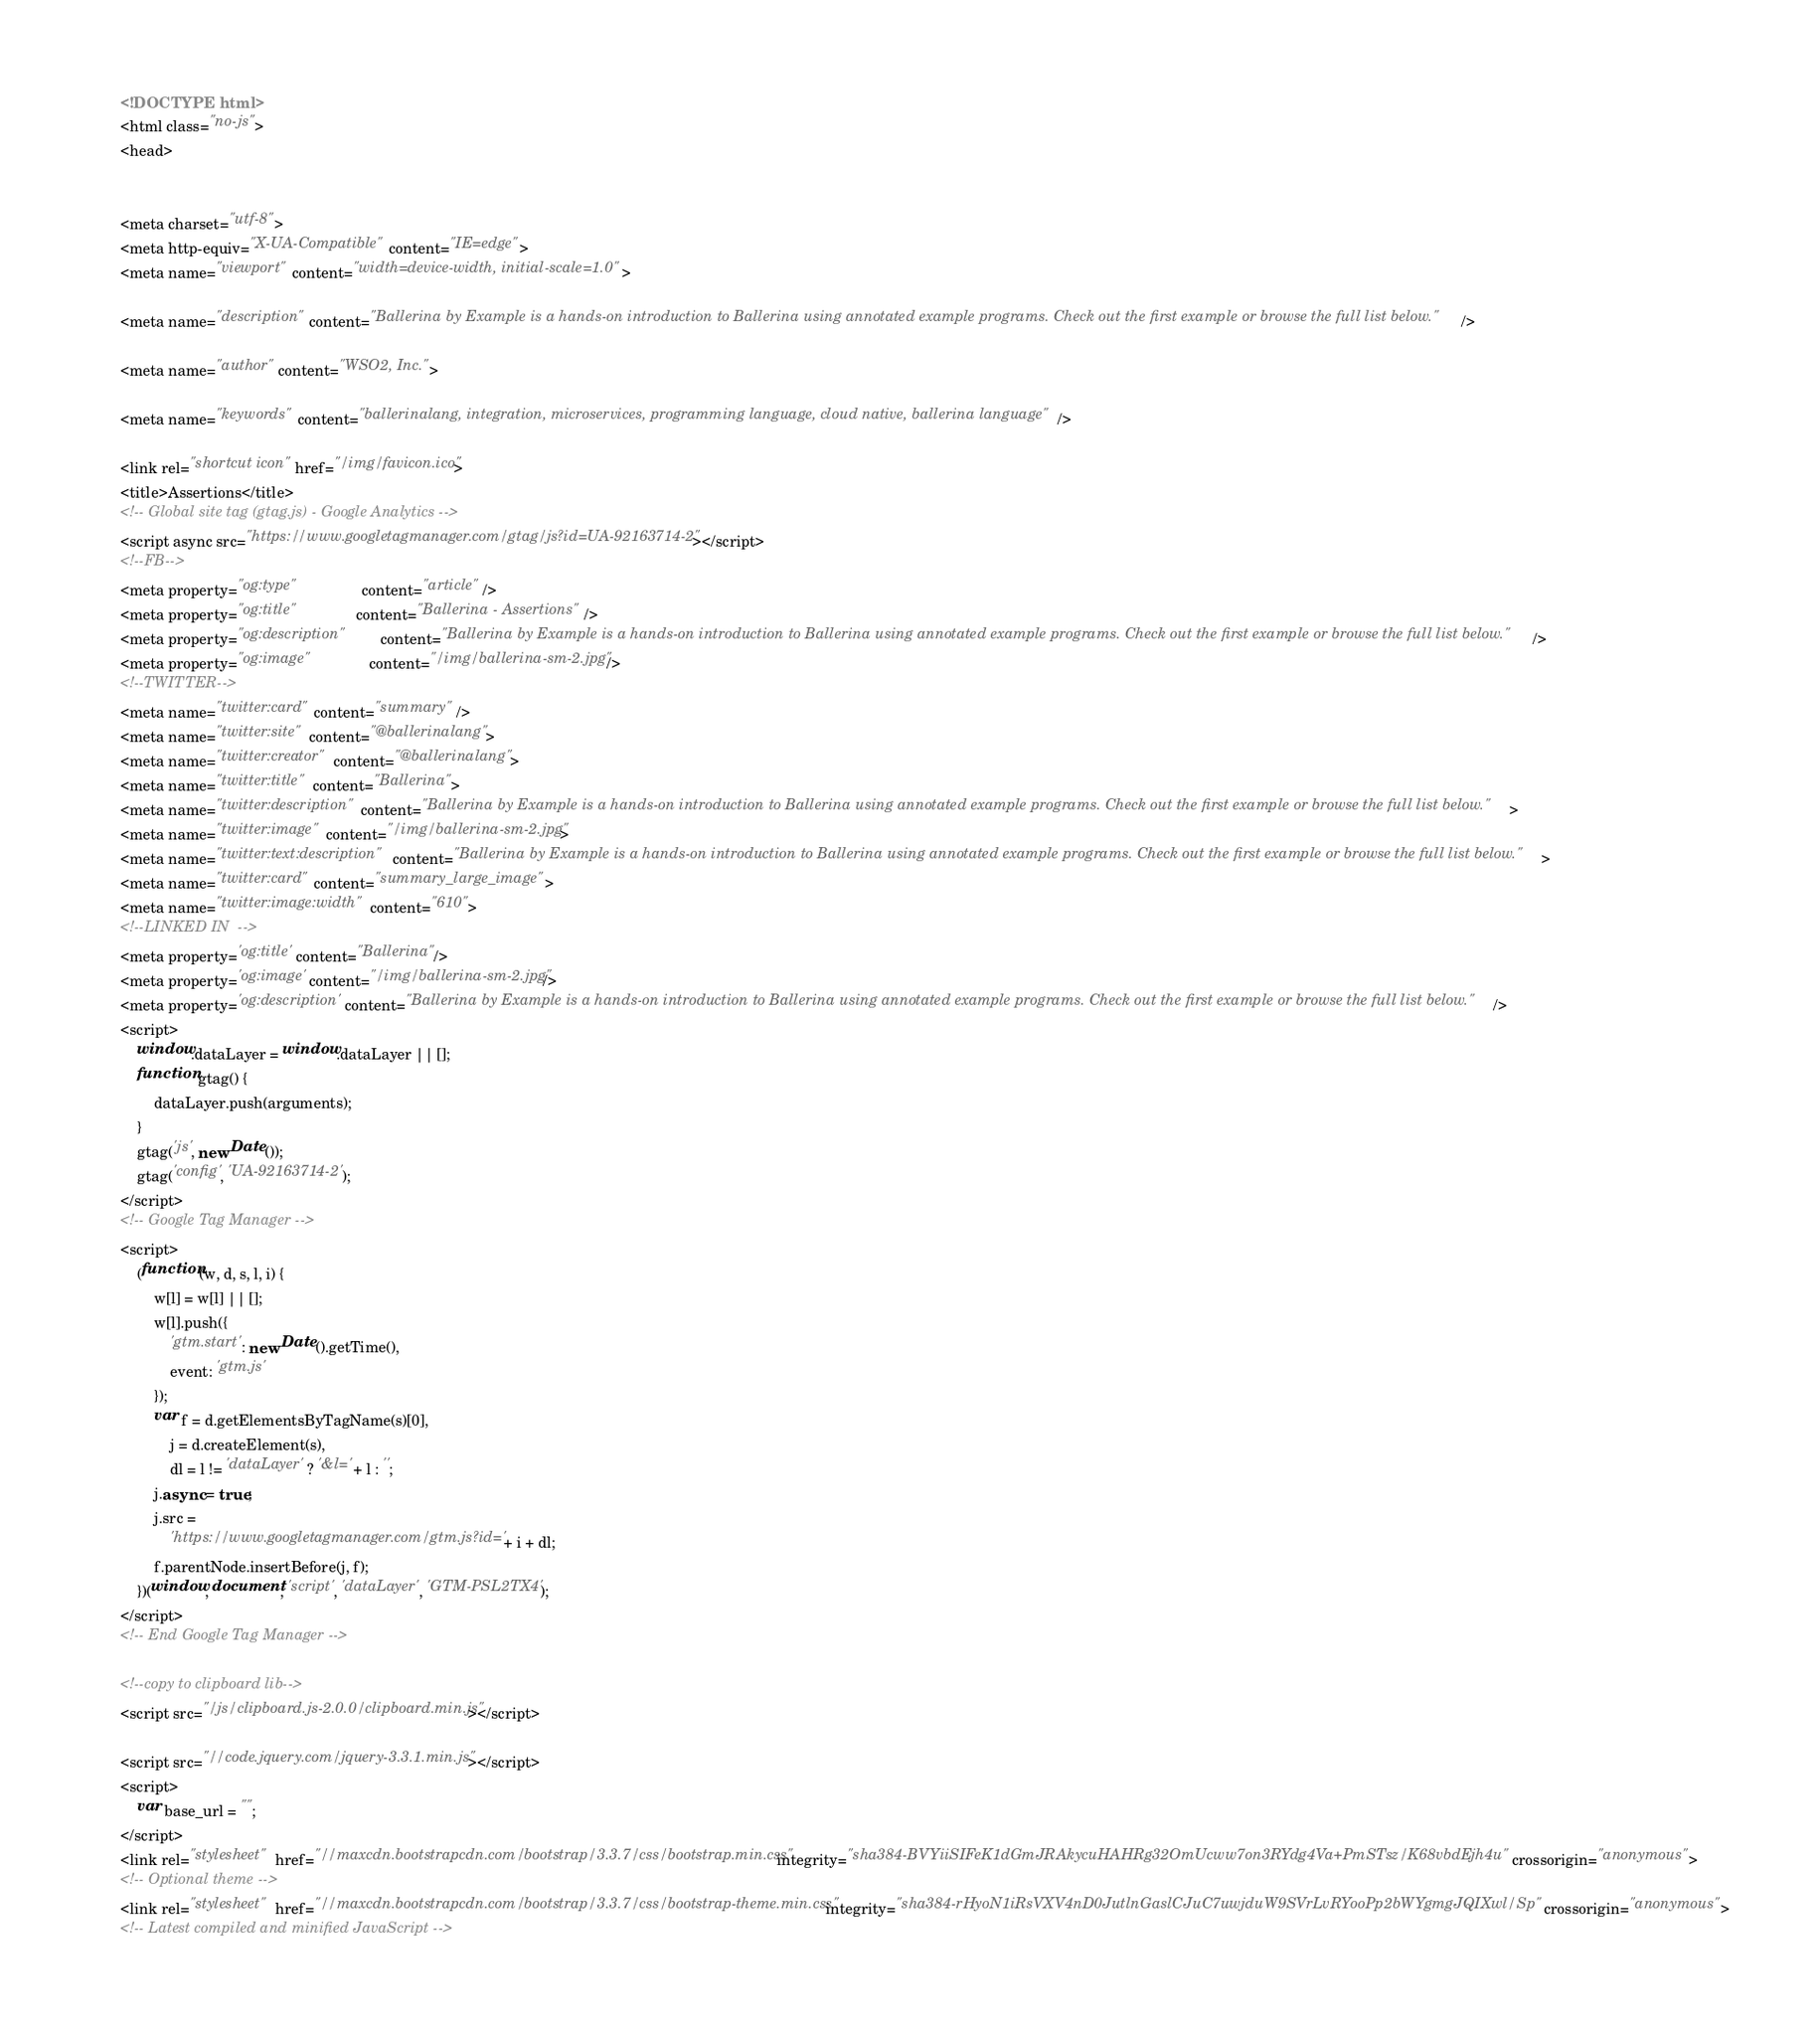<code> <loc_0><loc_0><loc_500><loc_500><_HTML_>

<!DOCTYPE html>
<html class="no-js">
<head>
    

<meta charset="utf-8">
<meta http-equiv="X-UA-Compatible" content="IE=edge">
<meta name="viewport" content="width=device-width, initial-scale=1.0">

<meta name="description" content="Ballerina by Example is a hands-on introduction to Ballerina using annotated example programs. Check out the first example or browse the full list below." />

<meta name="author" content="WSO2, Inc.">

<meta name="keywords" content="ballerinalang, integration, microservices, programming language, cloud native, ballerina language" />

<link rel="shortcut icon" href="/img/favicon.ico">
<title>Assertions</title>
<!-- Global site tag (gtag.js) - Google Analytics -->
<script async src="https://www.googletagmanager.com/gtag/js?id=UA-92163714-2"></script>
<!--FB-->
<meta property="og:type"               content="article" />
<meta property="og:title"              content="Ballerina - Assertions" />
<meta property="og:description"        content="Ballerina by Example is a hands-on introduction to Ballerina using annotated example programs. Check out the first example or browse the full list below." />
<meta property="og:image"              content="/img/ballerina-sm-2.jpg" />
<!--TWITTER-->
<meta name="twitter:card" content="summary" />
<meta name="twitter:site" content="@ballerinalang">
<meta name="twitter:creator" content="@ballerinalang">
<meta name="twitter:title" content="Ballerina">
<meta name="twitter:description" content="Ballerina by Example is a hands-on introduction to Ballerina using annotated example programs. Check out the first example or browse the full list below.">
<meta name="twitter:image" content="/img/ballerina-sm-2.jpg">
<meta name="twitter:text:description" content="Ballerina by Example is a hands-on introduction to Ballerina using annotated example programs. Check out the first example or browse the full list below.">
<meta name="twitter:card" content="summary_large_image">
<meta name="twitter:image:width" content="610">
<!--LINKED IN  -->
<meta property='og:title' content="Ballerina"/>
<meta property='og:image' content="/img/ballerina-sm-2.jpg"/>
<meta property='og:description' content="Ballerina by Example is a hands-on introduction to Ballerina using annotated example programs. Check out the first example or browse the full list below."/>
<script>
    window.dataLayer = window.dataLayer || [];
    function gtag() {
        dataLayer.push(arguments);
    }
    gtag('js', new Date());
    gtag('config', 'UA-92163714-2');
</script>
<!-- Google Tag Manager -->
<script>
    (function(w, d, s, l, i) {
        w[l] = w[l] || [];
        w[l].push({
            'gtm.start': new Date().getTime(),
            event: 'gtm.js'
        });
        var f = d.getElementsByTagName(s)[0],
            j = d.createElement(s),
            dl = l != 'dataLayer' ? '&l=' + l : '';
        j.async = true;
        j.src =
            'https://www.googletagmanager.com/gtm.js?id=' + i + dl;
        f.parentNode.insertBefore(j, f);
    })(window, document, 'script', 'dataLayer', 'GTM-PSL2TX4');
</script>
<!-- End Google Tag Manager -->

<!--copy to clipboard lib-->
<script src="/js/clipboard.js-2.0.0/clipboard.min.js"></script>

<script src="//code.jquery.com/jquery-3.3.1.min.js"></script>
<script>
    var base_url = "";
</script>
<link rel="stylesheet" href="//maxcdn.bootstrapcdn.com/bootstrap/3.3.7/css/bootstrap.min.css" integrity="sha384-BVYiiSIFeK1dGmJRAkycuHAHRg32OmUcww7on3RYdg4Va+PmSTsz/K68vbdEjh4u" crossorigin="anonymous">
<!-- Optional theme -->
<link rel="stylesheet" href="//maxcdn.bootstrapcdn.com/bootstrap/3.3.7/css/bootstrap-theme.min.css" integrity="sha384-rHyoN1iRsVXV4nD0JutlnGaslCJuC7uwjduW9SVrLvRYooPp2bWYgmgJQIXwl/Sp" crossorigin="anonymous">
<!-- Latest compiled and minified JavaScript --></code> 